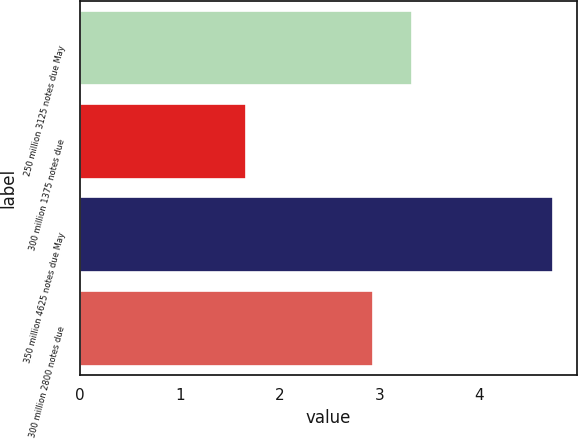Convert chart. <chart><loc_0><loc_0><loc_500><loc_500><bar_chart><fcel>250 million 3125 notes due May<fcel>300 million 1375 notes due<fcel>350 million 4625 notes due May<fcel>300 million 2800 notes due<nl><fcel>3.32<fcel>1.66<fcel>4.74<fcel>2.93<nl></chart> 